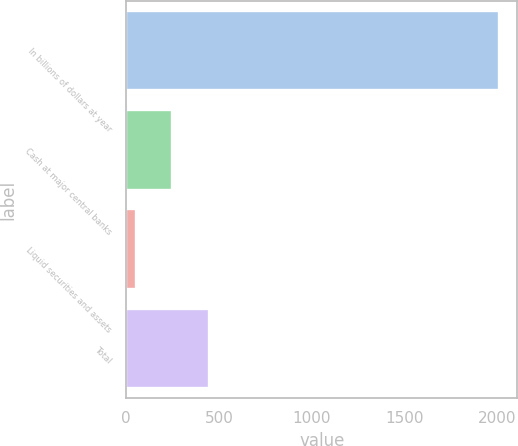Convert chart to OTSL. <chart><loc_0><loc_0><loc_500><loc_500><bar_chart><fcel>In billions of dollars at year<fcel>Cash at major central banks<fcel>Liquid securities and assets<fcel>Total<nl><fcel>2008<fcel>249.22<fcel>53.8<fcel>444.64<nl></chart> 